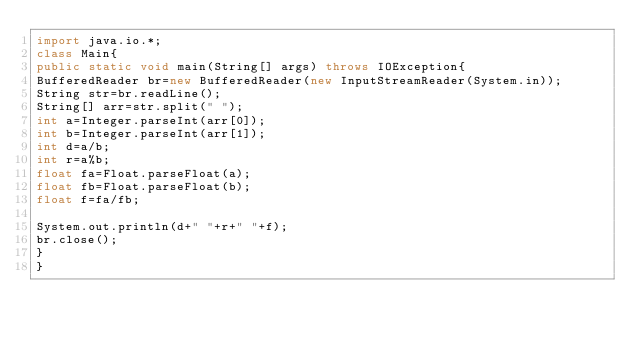<code> <loc_0><loc_0><loc_500><loc_500><_Java_>import java.io.*;
class Main{
public static void main(String[] args) throws IOException{
BufferedReader br=new BufferedReader(new InputStreamReader(System.in));
String str=br.readLine();
String[] arr=str.split(" ");
int a=Integer.parseInt(arr[0]);
int b=Integer.parseInt(arr[1]);
int d=a/b;
int r=a%b;
float fa=Float.parseFloat(a);
float fb=Float.parseFloat(b);
float f=fa/fb;

System.out.println(d+" "+r+" "+f);
br.close();
}
}</code> 